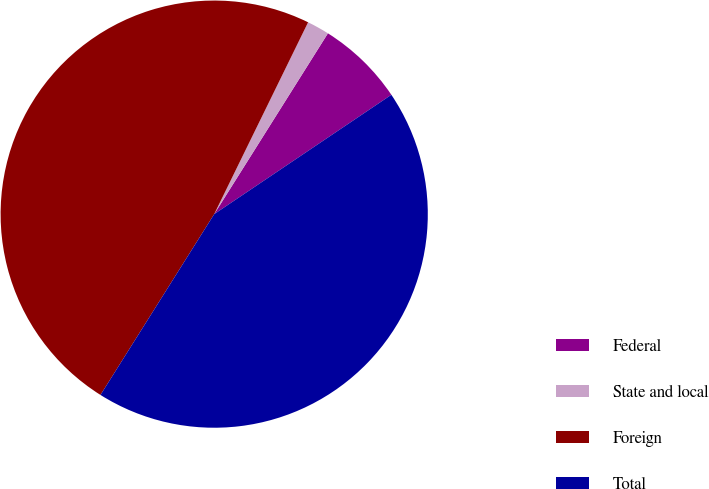Convert chart. <chart><loc_0><loc_0><loc_500><loc_500><pie_chart><fcel>Federal<fcel>State and local<fcel>Foreign<fcel>Total<nl><fcel>6.63%<fcel>1.69%<fcel>48.31%<fcel>43.37%<nl></chart> 